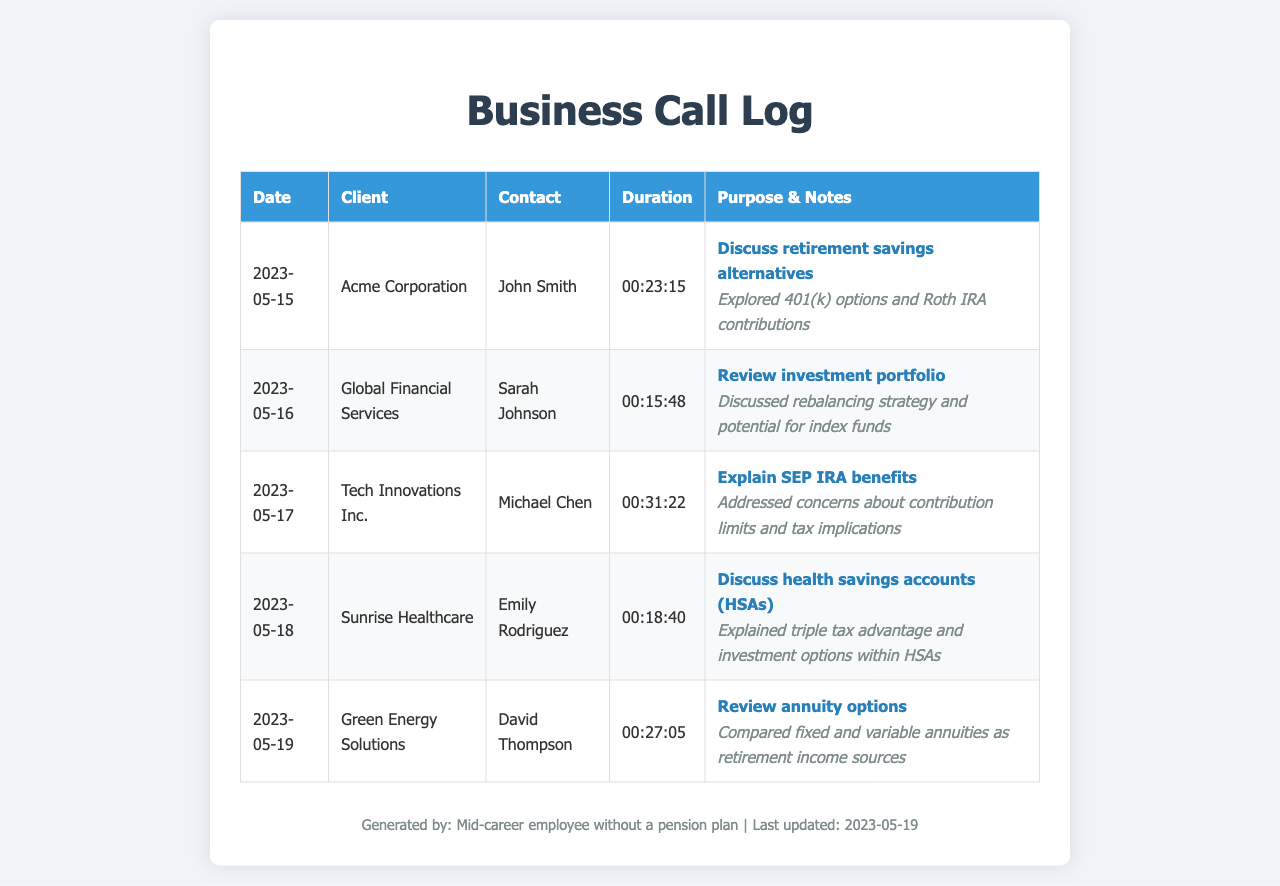What is the date of the call with Acme Corporation? The date of the call is listed in the first row of the table, which shows the call details for Acme Corporation.
Answer: 2023-05-15 Who is the contact person for Global Financial Services? The contact person is detailed in the second row of the table, which provides the call information for Global Financial Services.
Answer: Sarah Johnson What was the purpose of the call with Tech Innovations Inc.? The purpose is found in the fourth column of the table, outlining discussions held during the call with Tech Innovations Inc.
Answer: Explain SEP IRA benefits How many calls were made in total? The total number of calls can be counted based on the number of rows in the table.
Answer: 5 What was discussed during the call with Sunrise Healthcare? The notes section for Sunrise Healthcare provides insight into the specific details discussed during that call.
Answer: Explained triple tax advantage and investment options within HSAs What is the duration of the call with Green Energy Solutions? The duration is provided in the fourth column of the table for the call with Green Energy Solutions.
Answer: 00:27:05 Which company was the last call made to? The last entry in the table indicates which company was called last based on the date and order.
Answer: Green Energy Solutions 